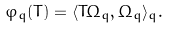Convert formula to latex. <formula><loc_0><loc_0><loc_500><loc_500>\varphi _ { q } ( T ) = \langle T \Omega _ { q } , \Omega _ { q } \rangle _ { q } .</formula> 